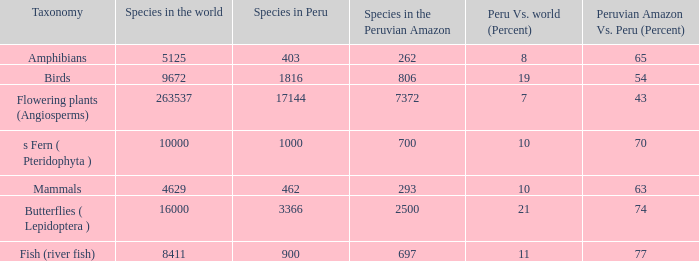What's the least number of species in the peruvian amazon having a peru vs. world (percent) value of 7? 7372.0. 